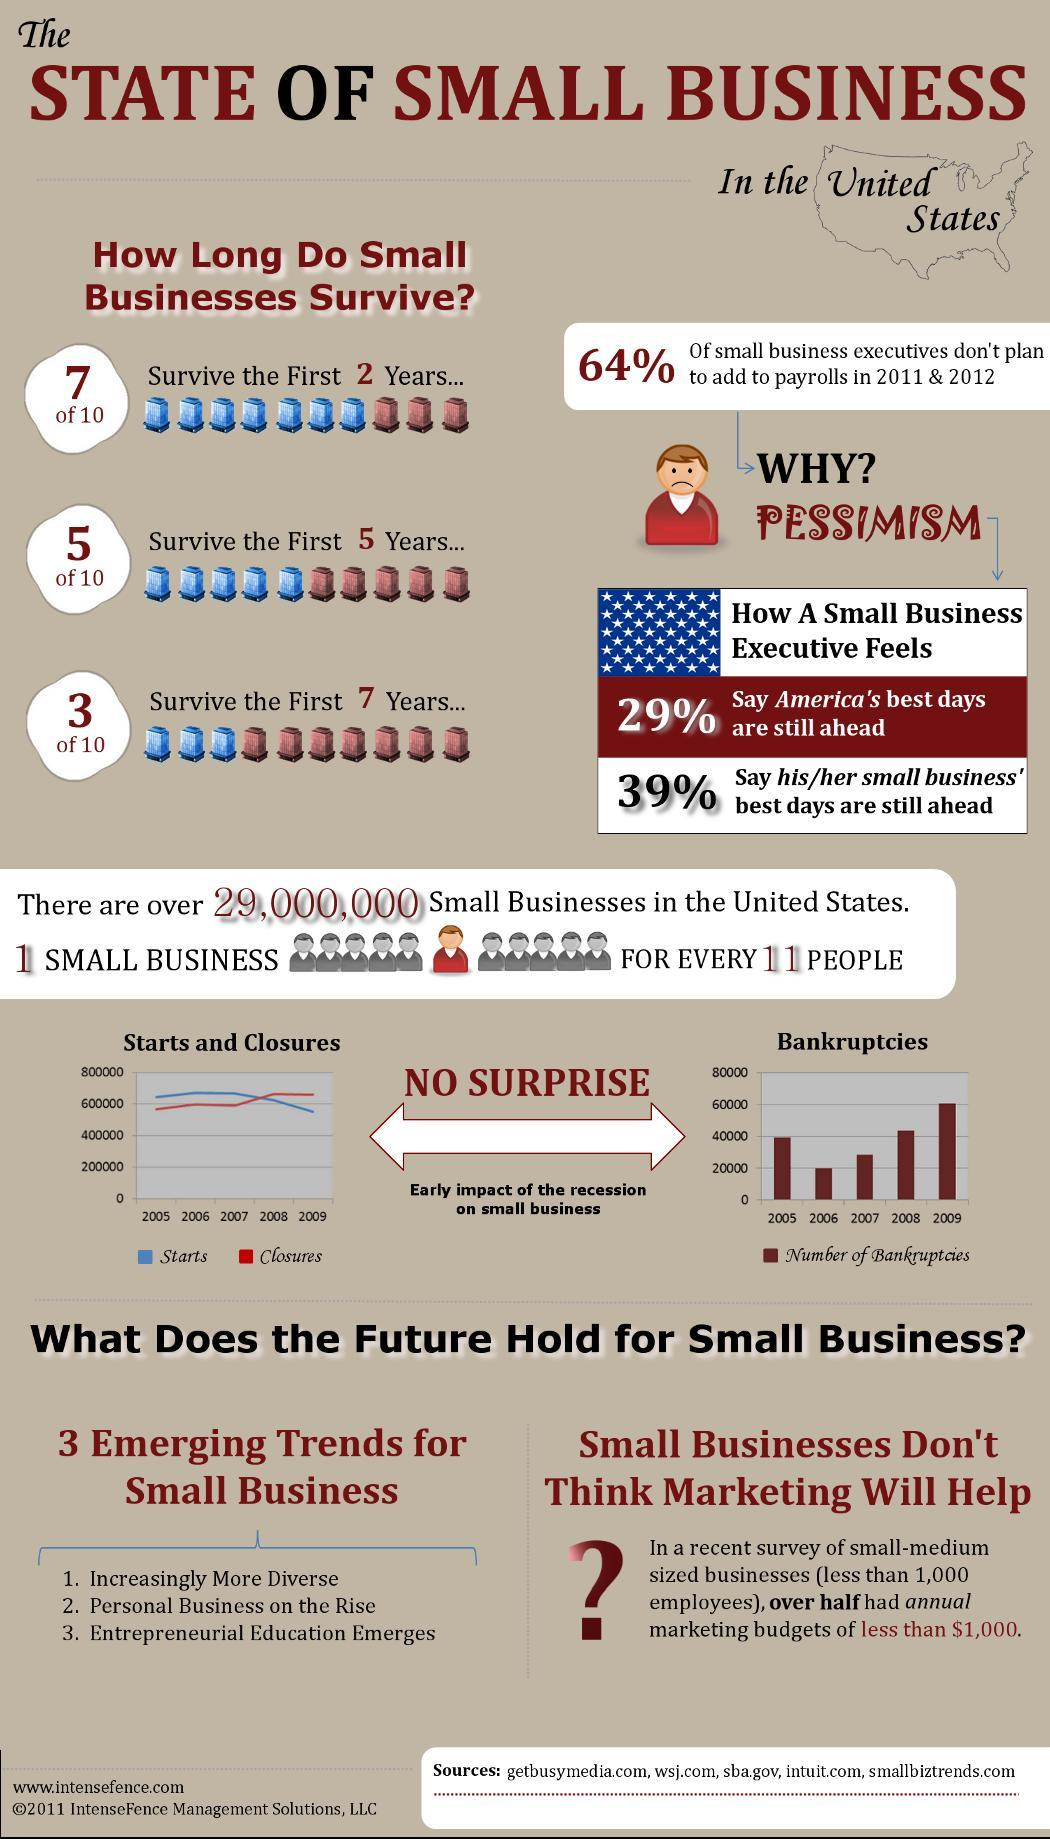what percentage of small business survive in the first 2 years
Answer the question with a short phrase. 70 what percentage of small business executives plan to add to payrolls in 2011 & 2012 36 what percentage of small business survive in the first 5 years 50 when was the number of bankruptcies the second highest 2008 what was the number of bankruptcies in 2007 3000 